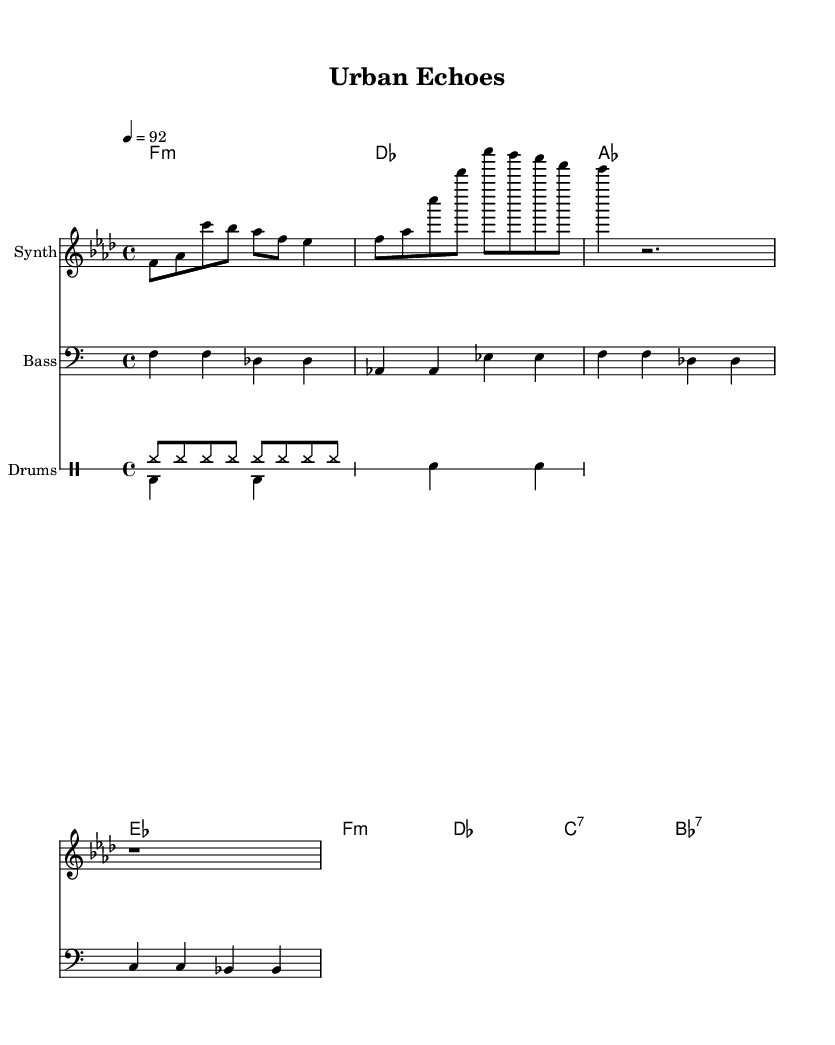What is the key signature of this music? The key signature is found at the beginning of the staff, which shows that there is one flat (B flat) for F minor.
Answer: F minor What is the time signature of this music? The time signature is located next to the key signature and indicates the number of beats per measure and what note value gets the beat, which is 4 beats per measure with a quarter note gets the beat.
Answer: 4/4 What is the tempo marking of this music? The tempo marking indicates how fast the music should be played, given in beats per minute. In this case, it is marked as 92 beats per minute.
Answer: 92 How many measures does the melody have? By counting the vertical lines, or bar lines, separating the notes, it can be observed that the melody section contains a total of 6 measures.
Answer: 6 What type of accompaniment is used in the drum pattern? The drum pattern consists mainly of hi-hats and bass drums, a common structure in electronic music, showcasing a repetitive rhythmic foundation without any complex syncopation.
Answer: Hi-hat and bass drum Which chords are used in the harmony section? By analyzing the chord symbols provided, the harmony section contains F minor, D flat major, A flat major, and E flat major chords, which are common in both electronic and hip-hop music.
Answer: F minor, D flat major, A flat major, E flat major What instrument is indicated for the melody line? The instrument name written in the staff section where the melody is notated indicates which instrument should play that line. In this case, it states that it should be played on a Synth.
Answer: Synth 